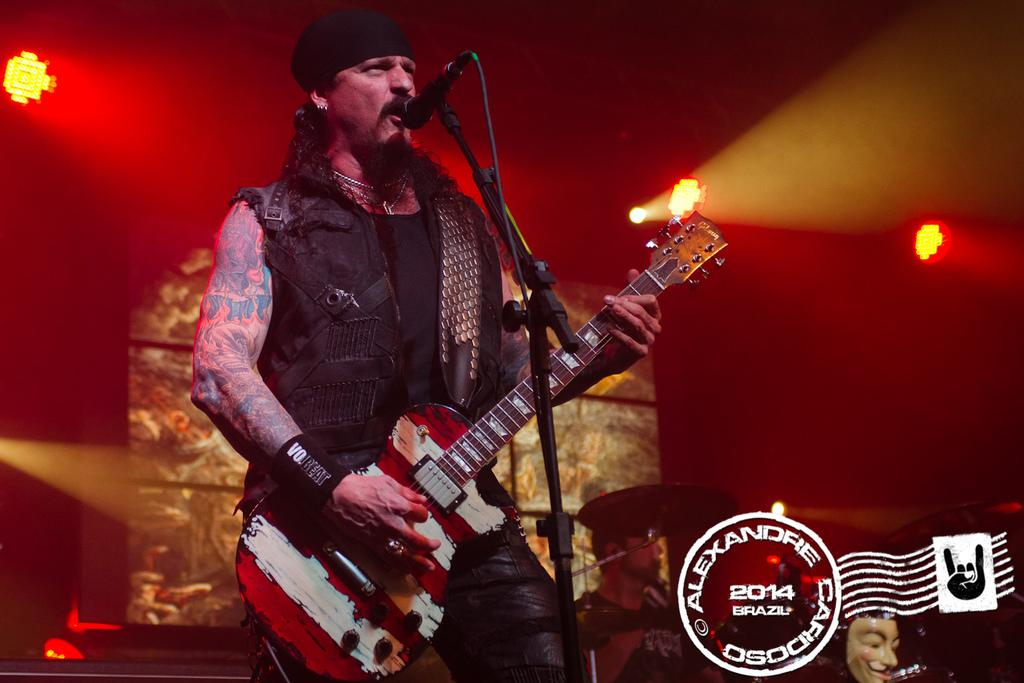What is the main subject of the image? The main subject of the image is a man. What is the man doing in the image? The man is standing, holding a guitar in his hand, and singing on a microphone. What can be seen in the man's hand? The man is holding a guitar in his hand. What else is visible in the image besides the man? There are lights visible in the image. What type of glove is the man wearing on his left hand while playing the guitar in the image? There is no glove visible on the man's hand in the image; he is holding a guitar without any gloves. What organization is the man representing in the image? The image does not provide any information about the man representing an organization. 